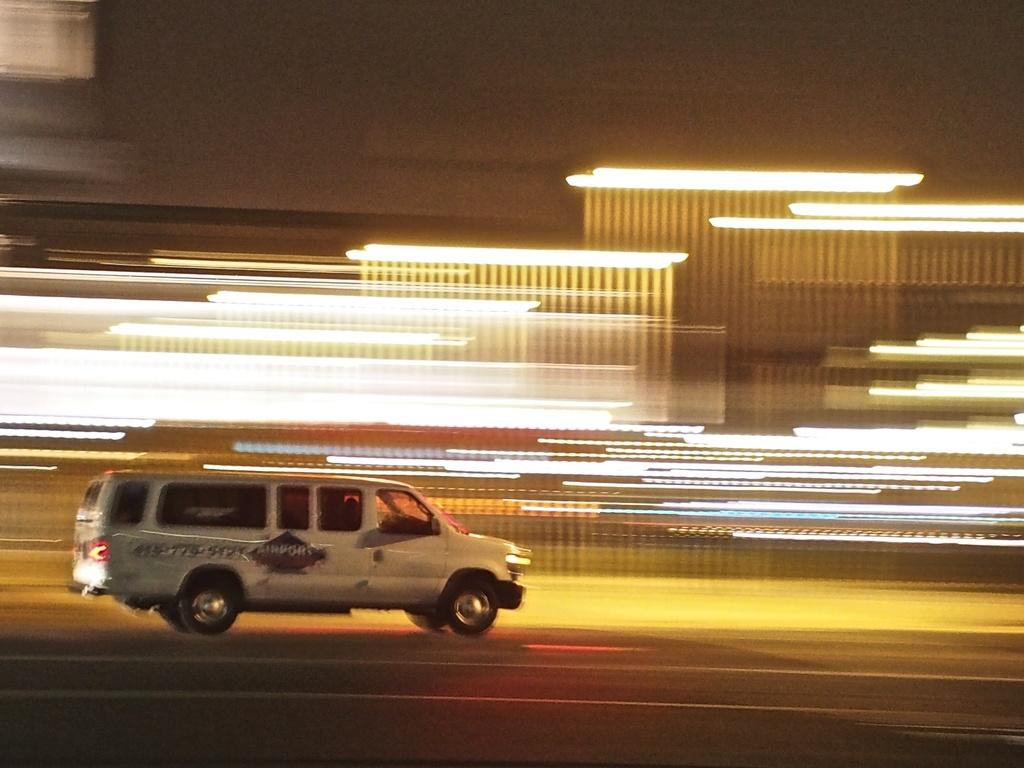What is on the road in the image? There is a vehicle on the road in the image. What else can be seen near the vehicle? There are lights beside the vehicle. What disease is the vehicle suffering from in the image? There is no indication of any disease in the image; it is a vehicle on the road with lights beside it. 